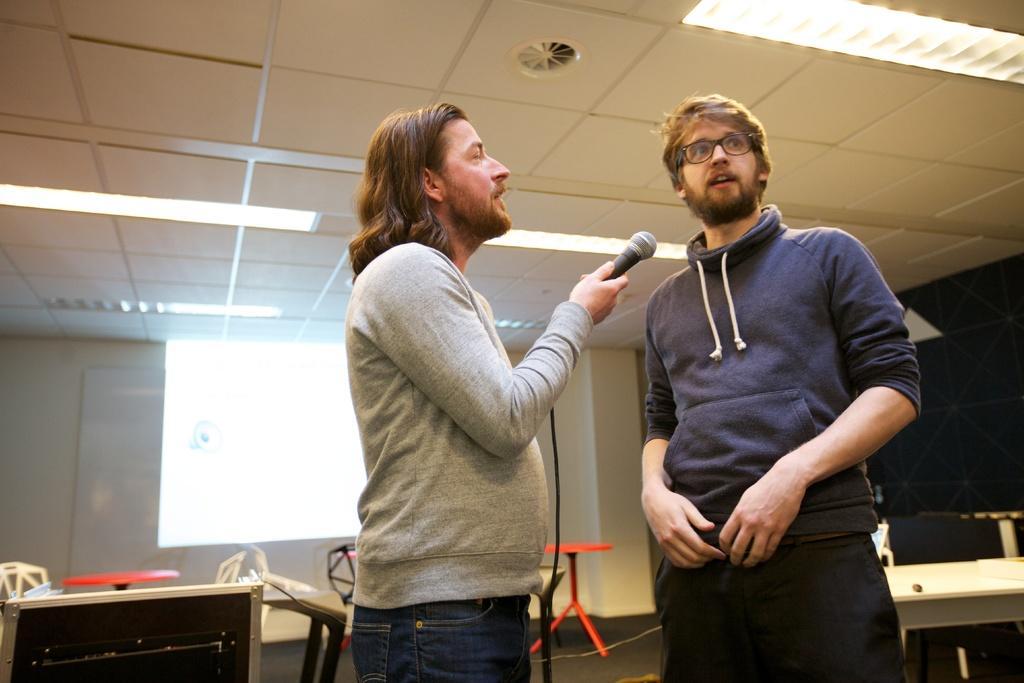Can you describe this image briefly? In this image we can see persons standing and holding mic. In the background we can see table, chairs, screen, board and wall. 